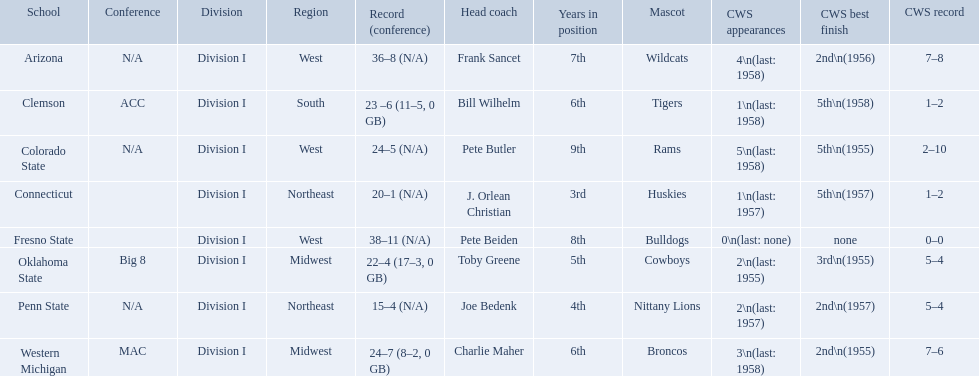What are all the school names? Arizona, Clemson, Colorado State, Connecticut, Fresno State, Oklahoma State, Penn State, Western Michigan. What is the record for each? 36–8 (N/A), 23 –6 (11–5, 0 GB), 24–5 (N/A), 20–1 (N/A), 38–11 (N/A), 22–4 (17–3, 0 GB), 15–4 (N/A), 24–7 (8–2, 0 GB). Which school had the fewest number of wins? Penn State. What are the teams in the conference? Arizona, Clemson, Colorado State, Connecticut, Fresno State, Oklahoma State, Penn State, Western Michigan. Which have more than 16 wins? Arizona, Clemson, Colorado State, Connecticut, Fresno State, Oklahoma State, Western Michigan. Which had less than 16 wins? Penn State. What are all of the schools? Arizona, Clemson, Colorado State, Connecticut, Fresno State, Oklahoma State, Penn State, Western Michigan. Which team had fewer than 20 wins? Penn State. 